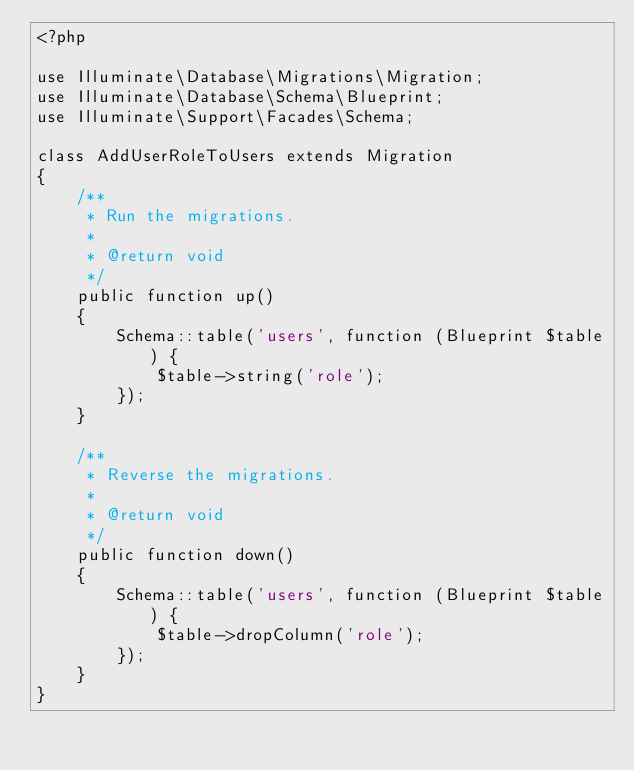<code> <loc_0><loc_0><loc_500><loc_500><_PHP_><?php

use Illuminate\Database\Migrations\Migration;
use Illuminate\Database\Schema\Blueprint;
use Illuminate\Support\Facades\Schema;

class AddUserRoleToUsers extends Migration
{
    /**
     * Run the migrations.
     *
     * @return void
     */
    public function up()
    {
        Schema::table('users', function (Blueprint $table) {
            $table->string('role');
        });
    }

    /**
     * Reverse the migrations.
     *
     * @return void
     */
    public function down()
    {
        Schema::table('users', function (Blueprint $table) {
            $table->dropColumn('role');
        });
    }
}
</code> 